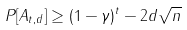<formula> <loc_0><loc_0><loc_500><loc_500>P [ A _ { t , d } ] \geq ( 1 - \gamma ) ^ { t } - 2 d \sqrt { n }</formula> 